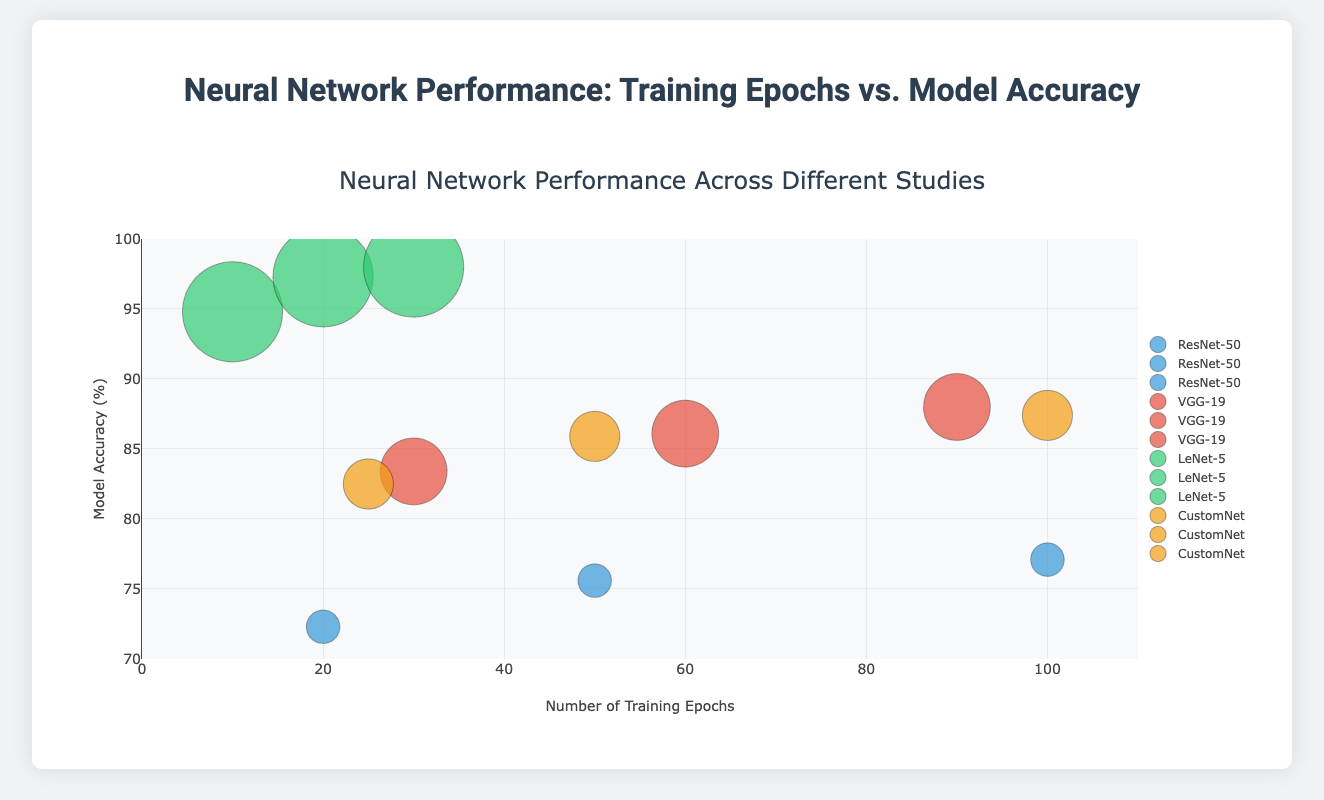What is the title of the figure? The title of the figure can be found at the top of the plot, which is "Neural Network Performance Across Different Studies".
Answer: Neural Network Performance Across Different Studies How many studies are represented in the chart? By examining the legends or the different study names, we can count that there are four distinct studies represented in the chart.
Answer: Four studies Which study had the highest maximum model accuracy? Looking at the highest point on the y-axis, the greatest y-value belongs to the study "Study 3 - MNIST Performance", where the accuracy reaches 98.0%.
Answer: Study 3 - MNIST Performance What is the training epochs and model accuracy for the largest bubble? The largest bubble on the chart is for "Study 3 - MNIST Performance" with a sample size of 300, which occurs at 30 epochs and an accuracy of 98.0%.
Answer: 30 epochs, 98.0% accuracy Which model from Study 4 has the highest accuracy, and at how many epochs? "CustomNet" from Study 4 has the highest accuracy of 87.4%, at 100 epochs.
Answer: CustomNet, 100 epochs What is the largest difference in model accuracy within Study 1? The difference in accuracy between 100 epochs (77.1%) and 20 epochs (72.3%) in Study 1 - ImageNet Performance is 77.1 - 72.3 = 4.8%.
Answer: 4.8% Between Study 2 and Study 4, which study achieved a higher accuracy at 50 epochs? At 50 epochs, Study 4 - Custom Dataset Performance (CustomNet) has an accuracy of 85.9%, while Study 2 - CIFAR-10 Performance (VGG-19) does not have data for 50 epochs. Hence, Study 4 has the higher accuracy at this point.
Answer: Study 4 - Custom Dataset Performance When comparing studies, which study reached near 95% accuracy first? "Study 3 - MNIST Performance" reached 94.8% accuracy at 10 training epochs, which is the closest to 95% and is the highest initial accuracy.
Answer: Study 3 - MNIST Performance How does the model accuracy of LeNet-5 change from 10 to 30 epochs? LeNet-5 (Study 3 - MNIST Performance) starts with 94.8% accuracy at 10 epochs, and its accuracy increases to 97.3% at 20 epochs, finally reaching 98.0% at 30 epochs, showing a steady increase.
Answer: Increases from 94.8% to 98.0% 